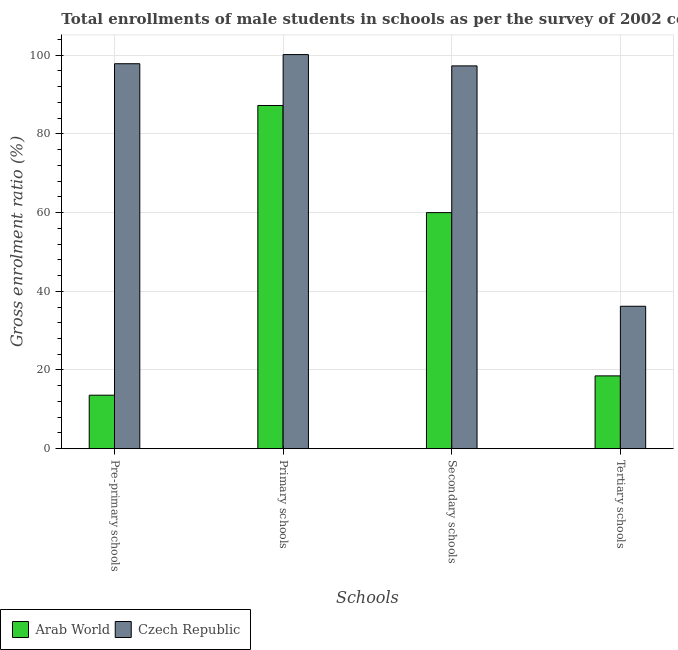How many groups of bars are there?
Offer a very short reply. 4. How many bars are there on the 4th tick from the left?
Offer a terse response. 2. How many bars are there on the 4th tick from the right?
Provide a succinct answer. 2. What is the label of the 3rd group of bars from the left?
Provide a short and direct response. Secondary schools. What is the gross enrolment ratio(male) in pre-primary schools in Arab World?
Your answer should be compact. 13.59. Across all countries, what is the maximum gross enrolment ratio(male) in pre-primary schools?
Provide a short and direct response. 97.83. Across all countries, what is the minimum gross enrolment ratio(male) in secondary schools?
Your answer should be compact. 59.99. In which country was the gross enrolment ratio(male) in pre-primary schools maximum?
Ensure brevity in your answer.  Czech Republic. In which country was the gross enrolment ratio(male) in secondary schools minimum?
Make the answer very short. Arab World. What is the total gross enrolment ratio(male) in pre-primary schools in the graph?
Provide a short and direct response. 111.42. What is the difference between the gross enrolment ratio(male) in pre-primary schools in Arab World and that in Czech Republic?
Give a very brief answer. -84.23. What is the difference between the gross enrolment ratio(male) in pre-primary schools in Arab World and the gross enrolment ratio(male) in tertiary schools in Czech Republic?
Your answer should be compact. -22.6. What is the average gross enrolment ratio(male) in pre-primary schools per country?
Give a very brief answer. 55.71. What is the difference between the gross enrolment ratio(male) in tertiary schools and gross enrolment ratio(male) in primary schools in Czech Republic?
Ensure brevity in your answer.  -63.96. In how many countries, is the gross enrolment ratio(male) in secondary schools greater than 56 %?
Ensure brevity in your answer.  2. What is the ratio of the gross enrolment ratio(male) in secondary schools in Czech Republic to that in Arab World?
Your answer should be very brief. 1.62. Is the gross enrolment ratio(male) in secondary schools in Arab World less than that in Czech Republic?
Provide a short and direct response. Yes. Is the difference between the gross enrolment ratio(male) in tertiary schools in Czech Republic and Arab World greater than the difference between the gross enrolment ratio(male) in secondary schools in Czech Republic and Arab World?
Make the answer very short. No. What is the difference between the highest and the second highest gross enrolment ratio(male) in primary schools?
Your answer should be very brief. 12.94. What is the difference between the highest and the lowest gross enrolment ratio(male) in primary schools?
Ensure brevity in your answer.  12.94. In how many countries, is the gross enrolment ratio(male) in secondary schools greater than the average gross enrolment ratio(male) in secondary schools taken over all countries?
Keep it short and to the point. 1. Is the sum of the gross enrolment ratio(male) in pre-primary schools in Czech Republic and Arab World greater than the maximum gross enrolment ratio(male) in secondary schools across all countries?
Your answer should be compact. Yes. Is it the case that in every country, the sum of the gross enrolment ratio(male) in secondary schools and gross enrolment ratio(male) in primary schools is greater than the sum of gross enrolment ratio(male) in tertiary schools and gross enrolment ratio(male) in pre-primary schools?
Provide a succinct answer. No. What does the 1st bar from the left in Pre-primary schools represents?
Give a very brief answer. Arab World. What does the 1st bar from the right in Primary schools represents?
Make the answer very short. Czech Republic. Is it the case that in every country, the sum of the gross enrolment ratio(male) in pre-primary schools and gross enrolment ratio(male) in primary schools is greater than the gross enrolment ratio(male) in secondary schools?
Offer a very short reply. Yes. How many bars are there?
Your answer should be very brief. 8. What is the difference between two consecutive major ticks on the Y-axis?
Give a very brief answer. 20. Are the values on the major ticks of Y-axis written in scientific E-notation?
Offer a very short reply. No. Does the graph contain any zero values?
Your response must be concise. No. Where does the legend appear in the graph?
Your answer should be very brief. Bottom left. How many legend labels are there?
Your answer should be very brief. 2. How are the legend labels stacked?
Ensure brevity in your answer.  Horizontal. What is the title of the graph?
Your answer should be compact. Total enrollments of male students in schools as per the survey of 2002 conducted in different countries. What is the label or title of the X-axis?
Offer a very short reply. Schools. What is the label or title of the Y-axis?
Provide a short and direct response. Gross enrolment ratio (%). What is the Gross enrolment ratio (%) of Arab World in Pre-primary schools?
Keep it short and to the point. 13.59. What is the Gross enrolment ratio (%) in Czech Republic in Pre-primary schools?
Provide a short and direct response. 97.83. What is the Gross enrolment ratio (%) in Arab World in Primary schools?
Provide a short and direct response. 87.21. What is the Gross enrolment ratio (%) in Czech Republic in Primary schools?
Keep it short and to the point. 100.15. What is the Gross enrolment ratio (%) in Arab World in Secondary schools?
Offer a terse response. 59.99. What is the Gross enrolment ratio (%) in Czech Republic in Secondary schools?
Offer a very short reply. 97.28. What is the Gross enrolment ratio (%) in Arab World in Tertiary schools?
Your answer should be compact. 18.5. What is the Gross enrolment ratio (%) of Czech Republic in Tertiary schools?
Provide a succinct answer. 36.19. Across all Schools, what is the maximum Gross enrolment ratio (%) of Arab World?
Keep it short and to the point. 87.21. Across all Schools, what is the maximum Gross enrolment ratio (%) in Czech Republic?
Offer a very short reply. 100.15. Across all Schools, what is the minimum Gross enrolment ratio (%) in Arab World?
Provide a succinct answer. 13.59. Across all Schools, what is the minimum Gross enrolment ratio (%) in Czech Republic?
Offer a very short reply. 36.19. What is the total Gross enrolment ratio (%) in Arab World in the graph?
Give a very brief answer. 179.3. What is the total Gross enrolment ratio (%) in Czech Republic in the graph?
Make the answer very short. 331.45. What is the difference between the Gross enrolment ratio (%) in Arab World in Pre-primary schools and that in Primary schools?
Your response must be concise. -73.62. What is the difference between the Gross enrolment ratio (%) of Czech Republic in Pre-primary schools and that in Primary schools?
Your response must be concise. -2.33. What is the difference between the Gross enrolment ratio (%) in Arab World in Pre-primary schools and that in Secondary schools?
Your answer should be very brief. -46.4. What is the difference between the Gross enrolment ratio (%) in Czech Republic in Pre-primary schools and that in Secondary schools?
Offer a very short reply. 0.55. What is the difference between the Gross enrolment ratio (%) of Arab World in Pre-primary schools and that in Tertiary schools?
Your response must be concise. -4.91. What is the difference between the Gross enrolment ratio (%) in Czech Republic in Pre-primary schools and that in Tertiary schools?
Your answer should be compact. 61.63. What is the difference between the Gross enrolment ratio (%) of Arab World in Primary schools and that in Secondary schools?
Provide a short and direct response. 27.22. What is the difference between the Gross enrolment ratio (%) in Czech Republic in Primary schools and that in Secondary schools?
Your answer should be very brief. 2.87. What is the difference between the Gross enrolment ratio (%) of Arab World in Primary schools and that in Tertiary schools?
Offer a very short reply. 68.71. What is the difference between the Gross enrolment ratio (%) of Czech Republic in Primary schools and that in Tertiary schools?
Your response must be concise. 63.96. What is the difference between the Gross enrolment ratio (%) in Arab World in Secondary schools and that in Tertiary schools?
Your answer should be very brief. 41.49. What is the difference between the Gross enrolment ratio (%) in Czech Republic in Secondary schools and that in Tertiary schools?
Your answer should be compact. 61.08. What is the difference between the Gross enrolment ratio (%) of Arab World in Pre-primary schools and the Gross enrolment ratio (%) of Czech Republic in Primary schools?
Ensure brevity in your answer.  -86.56. What is the difference between the Gross enrolment ratio (%) of Arab World in Pre-primary schools and the Gross enrolment ratio (%) of Czech Republic in Secondary schools?
Give a very brief answer. -83.69. What is the difference between the Gross enrolment ratio (%) of Arab World in Pre-primary schools and the Gross enrolment ratio (%) of Czech Republic in Tertiary schools?
Provide a short and direct response. -22.6. What is the difference between the Gross enrolment ratio (%) of Arab World in Primary schools and the Gross enrolment ratio (%) of Czech Republic in Secondary schools?
Offer a terse response. -10.06. What is the difference between the Gross enrolment ratio (%) in Arab World in Primary schools and the Gross enrolment ratio (%) in Czech Republic in Tertiary schools?
Give a very brief answer. 51.02. What is the difference between the Gross enrolment ratio (%) in Arab World in Secondary schools and the Gross enrolment ratio (%) in Czech Republic in Tertiary schools?
Provide a succinct answer. 23.8. What is the average Gross enrolment ratio (%) in Arab World per Schools?
Provide a succinct answer. 44.82. What is the average Gross enrolment ratio (%) of Czech Republic per Schools?
Your response must be concise. 82.86. What is the difference between the Gross enrolment ratio (%) of Arab World and Gross enrolment ratio (%) of Czech Republic in Pre-primary schools?
Give a very brief answer. -84.23. What is the difference between the Gross enrolment ratio (%) in Arab World and Gross enrolment ratio (%) in Czech Republic in Primary schools?
Provide a short and direct response. -12.94. What is the difference between the Gross enrolment ratio (%) in Arab World and Gross enrolment ratio (%) in Czech Republic in Secondary schools?
Give a very brief answer. -37.29. What is the difference between the Gross enrolment ratio (%) in Arab World and Gross enrolment ratio (%) in Czech Republic in Tertiary schools?
Your answer should be compact. -17.69. What is the ratio of the Gross enrolment ratio (%) of Arab World in Pre-primary schools to that in Primary schools?
Your response must be concise. 0.16. What is the ratio of the Gross enrolment ratio (%) of Czech Republic in Pre-primary schools to that in Primary schools?
Your answer should be very brief. 0.98. What is the ratio of the Gross enrolment ratio (%) of Arab World in Pre-primary schools to that in Secondary schools?
Your response must be concise. 0.23. What is the ratio of the Gross enrolment ratio (%) in Czech Republic in Pre-primary schools to that in Secondary schools?
Your answer should be compact. 1.01. What is the ratio of the Gross enrolment ratio (%) in Arab World in Pre-primary schools to that in Tertiary schools?
Offer a very short reply. 0.73. What is the ratio of the Gross enrolment ratio (%) of Czech Republic in Pre-primary schools to that in Tertiary schools?
Your answer should be very brief. 2.7. What is the ratio of the Gross enrolment ratio (%) in Arab World in Primary schools to that in Secondary schools?
Ensure brevity in your answer.  1.45. What is the ratio of the Gross enrolment ratio (%) of Czech Republic in Primary schools to that in Secondary schools?
Provide a succinct answer. 1.03. What is the ratio of the Gross enrolment ratio (%) in Arab World in Primary schools to that in Tertiary schools?
Give a very brief answer. 4.71. What is the ratio of the Gross enrolment ratio (%) in Czech Republic in Primary schools to that in Tertiary schools?
Ensure brevity in your answer.  2.77. What is the ratio of the Gross enrolment ratio (%) in Arab World in Secondary schools to that in Tertiary schools?
Offer a very short reply. 3.24. What is the ratio of the Gross enrolment ratio (%) of Czech Republic in Secondary schools to that in Tertiary schools?
Ensure brevity in your answer.  2.69. What is the difference between the highest and the second highest Gross enrolment ratio (%) of Arab World?
Give a very brief answer. 27.22. What is the difference between the highest and the second highest Gross enrolment ratio (%) in Czech Republic?
Offer a very short reply. 2.33. What is the difference between the highest and the lowest Gross enrolment ratio (%) in Arab World?
Offer a terse response. 73.62. What is the difference between the highest and the lowest Gross enrolment ratio (%) of Czech Republic?
Offer a terse response. 63.96. 